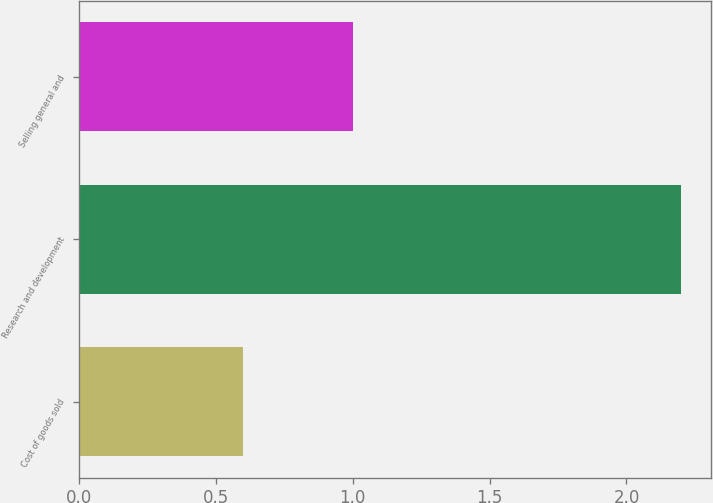Convert chart to OTSL. <chart><loc_0><loc_0><loc_500><loc_500><bar_chart><fcel>Cost of goods sold<fcel>Research and development<fcel>Selling general and<nl><fcel>0.6<fcel>2.2<fcel>1<nl></chart> 